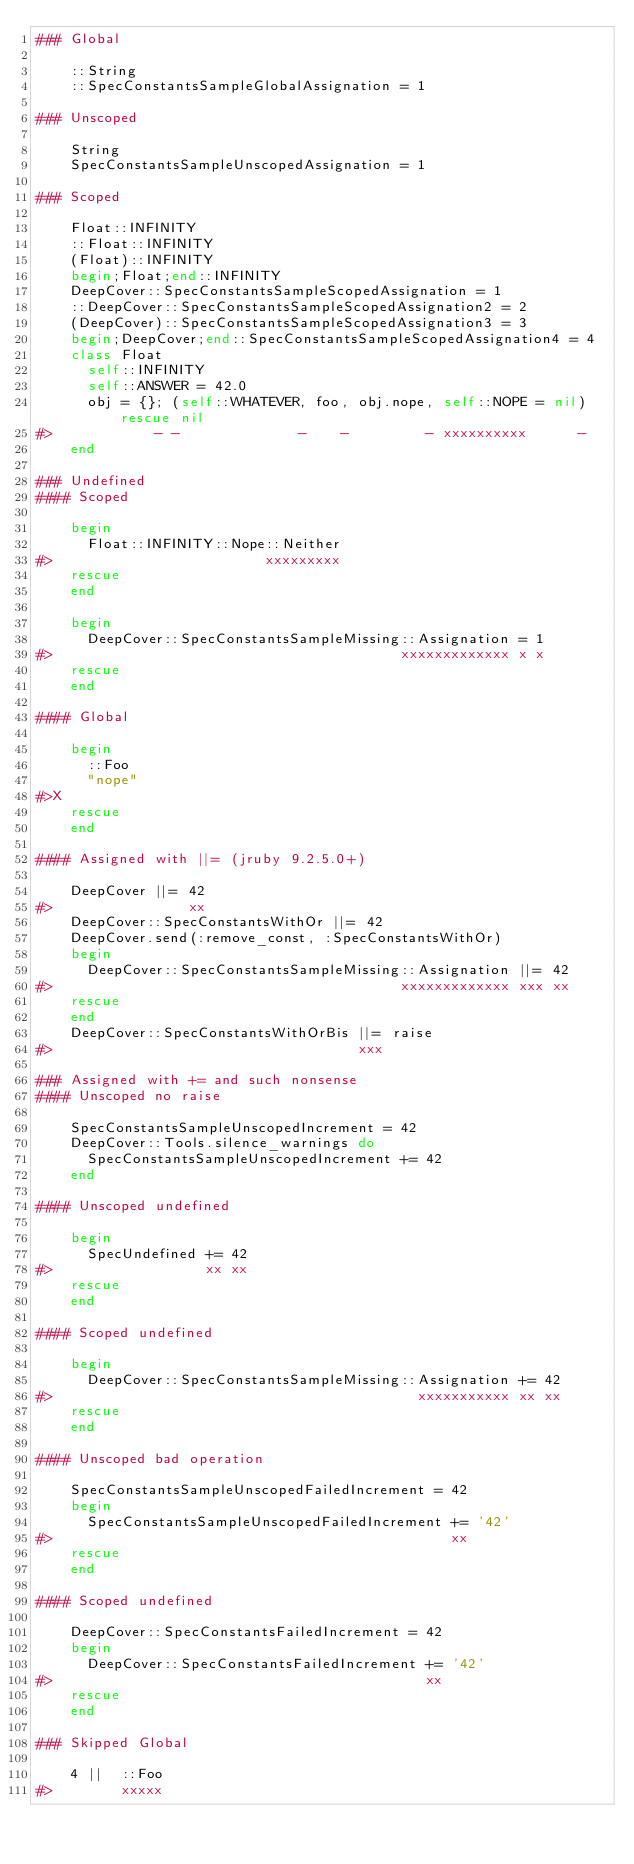Convert code to text. <code><loc_0><loc_0><loc_500><loc_500><_Ruby_>### Global

    ::String
    ::SpecConstantsSampleGlobalAssignation = 1

### Unscoped

    String
    SpecConstantsSampleUnscopedAssignation = 1

### Scoped

    Float::INFINITY
    ::Float::INFINITY
    (Float)::INFINITY
    begin;Float;end::INFINITY
    DeepCover::SpecConstantsSampleScopedAssignation = 1
    ::DeepCover::SpecConstantsSampleScopedAssignation2 = 2
    (DeepCover)::SpecConstantsSampleScopedAssignation3 = 3
    begin;DeepCover;end::SpecConstantsSampleScopedAssignation4 = 4
    class Float
      self::INFINITY
      self::ANSWER = 42.0
      obj = {}; (self::WHATEVER, foo, obj.nope, self::NOPE = nil) rescue nil
#>            - -              -    -         - xxxxxxxxxx      -
    end

### Undefined
#### Scoped

    begin
      Float::INFINITY::Nope::Neither
#>                         xxxxxxxxx
    rescue
    end

    begin
      DeepCover::SpecConstantsSampleMissing::Assignation = 1
#>                                         xxxxxxxxxxxxx x x
    rescue
    end

#### Global

    begin
      ::Foo
      "nope"
#>X
    rescue
    end

#### Assigned with ||= (jruby 9.2.5.0+)

    DeepCover ||= 42
#>                xx
    DeepCover::SpecConstantsWithOr ||= 42
    DeepCover.send(:remove_const, :SpecConstantsWithOr)
    begin
      DeepCover::SpecConstantsSampleMissing::Assignation ||= 42
#>                                         xxxxxxxxxxxxx xxx xx
    rescue
    end
    DeepCover::SpecConstantsWithOrBis ||= raise
#>                                    xxx

### Assigned with += and such nonsense
#### Unscoped no raise

    SpecConstantsSampleUnscopedIncrement = 42
    DeepCover::Tools.silence_warnings do
      SpecConstantsSampleUnscopedIncrement += 42
    end

#### Unscoped undefined

    begin
      SpecUndefined += 42
#>                  xx xx
    rescue
    end

#### Scoped undefined

    begin
      DeepCover::SpecConstantsSampleMissing::Assignation += 42
#>                                           xxxxxxxxxxx xx xx
    rescue
    end

#### Unscoped bad operation

    SpecConstantsSampleUnscopedFailedIncrement = 42
    begin
      SpecConstantsSampleUnscopedFailedIncrement += '42'
#>                                               xx
    rescue
    end

#### Scoped undefined

    DeepCover::SpecConstantsFailedIncrement = 42
    begin
      DeepCover::SpecConstantsFailedIncrement += '42'
#>                                            xx
    rescue
    end

### Skipped Global

    4 ||  ::Foo
#>        xxxxx
</code> 